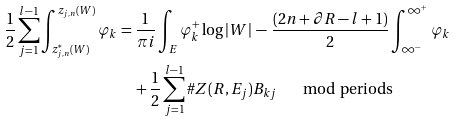<formula> <loc_0><loc_0><loc_500><loc_500>\frac { 1 } { 2 } \sum _ { j = 1 } ^ { l - 1 } \int _ { z _ { j , n } ^ { * } ( W ) } ^ { z _ { j , n } ( W ) } { \varphi _ { k } } & = \frac { 1 } { \pi i } \int _ { E } \varphi _ { k } ^ { + } \log { | W | } \, - \, \frac { ( 2 n + \partial R - l + 1 ) } { 2 } \int _ { \infty ^ { - } } ^ { \infty ^ { + } } { \varphi _ { k } } \\ & \quad + \frac { 1 } { 2 } \sum _ { j = 1 } ^ { l - 1 } \# Z ( R , E _ { j } ) B _ { k j } \quad \mod \text {periods}</formula> 